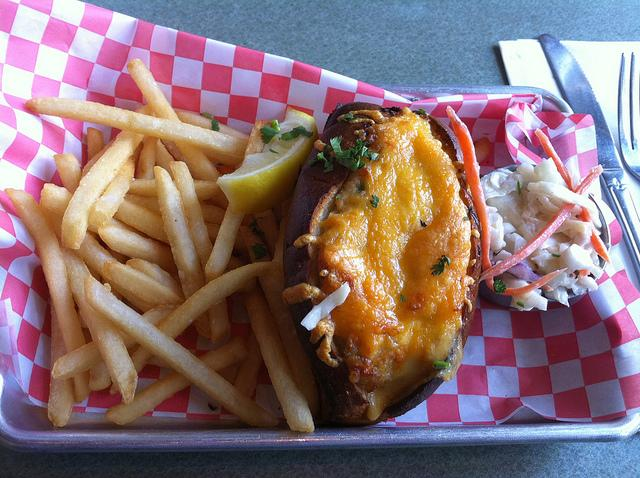Which food item on the plate is highest in fat?

Choices:
A) cheese
B) coleslaw
C) potato skin
D) french fries cheese 